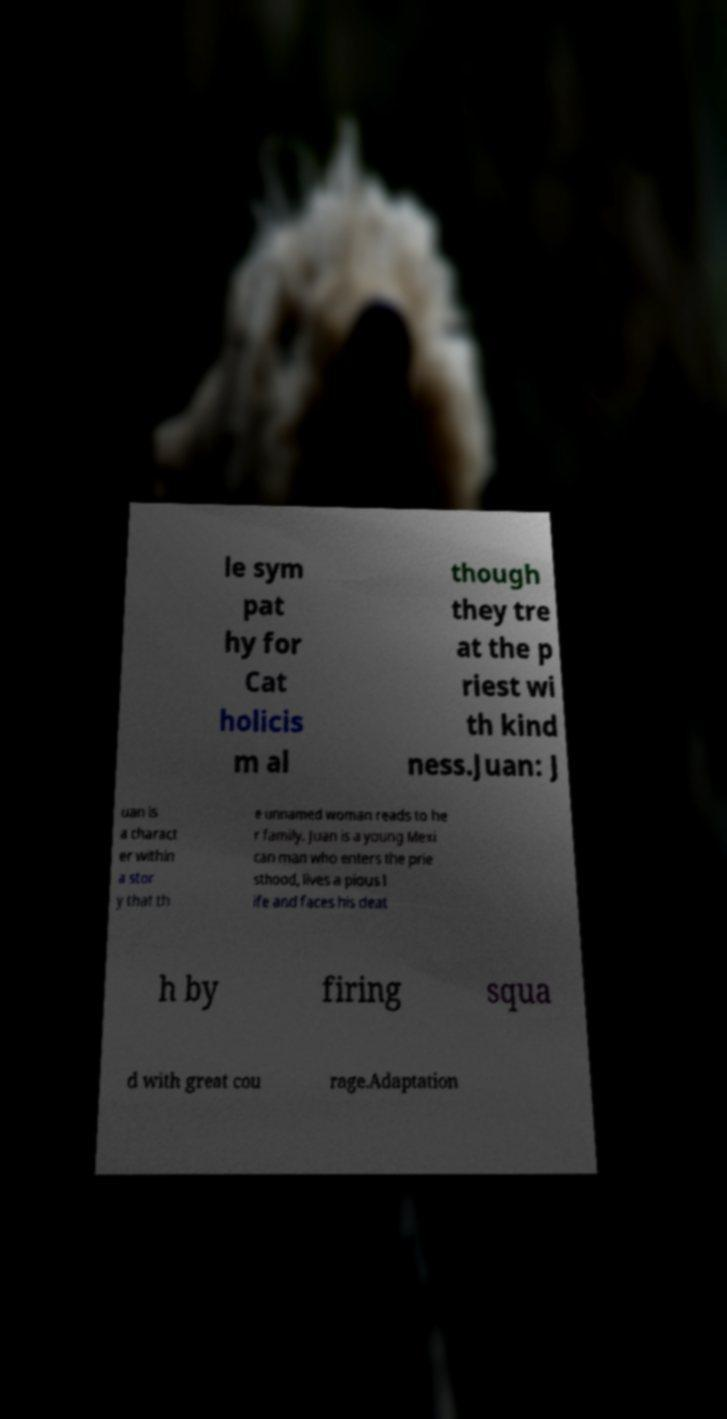Could you extract and type out the text from this image? le sym pat hy for Cat holicis m al though they tre at the p riest wi th kind ness.Juan: J uan is a charact er within a stor y that th e unnamed woman reads to he r family. Juan is a young Mexi can man who enters the prie sthood, lives a pious l ife and faces his deat h by firing squa d with great cou rage.Adaptation 